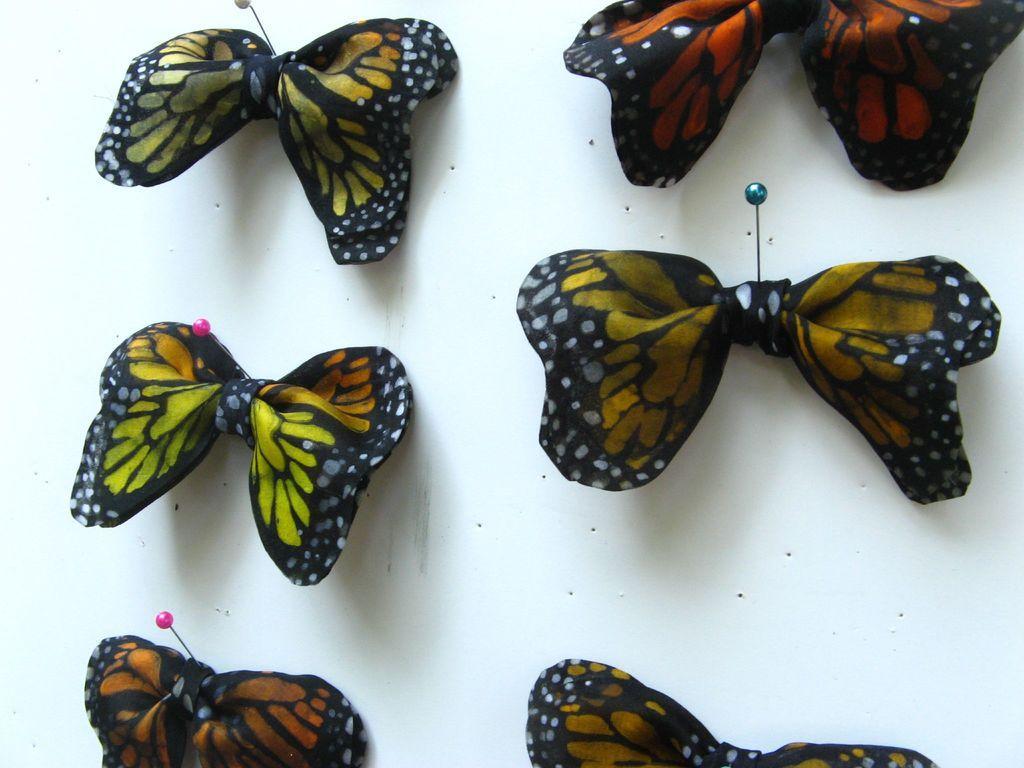Could you give a brief overview of what you see in this image? Here we can see butterflies with ribbons on a white platform. 